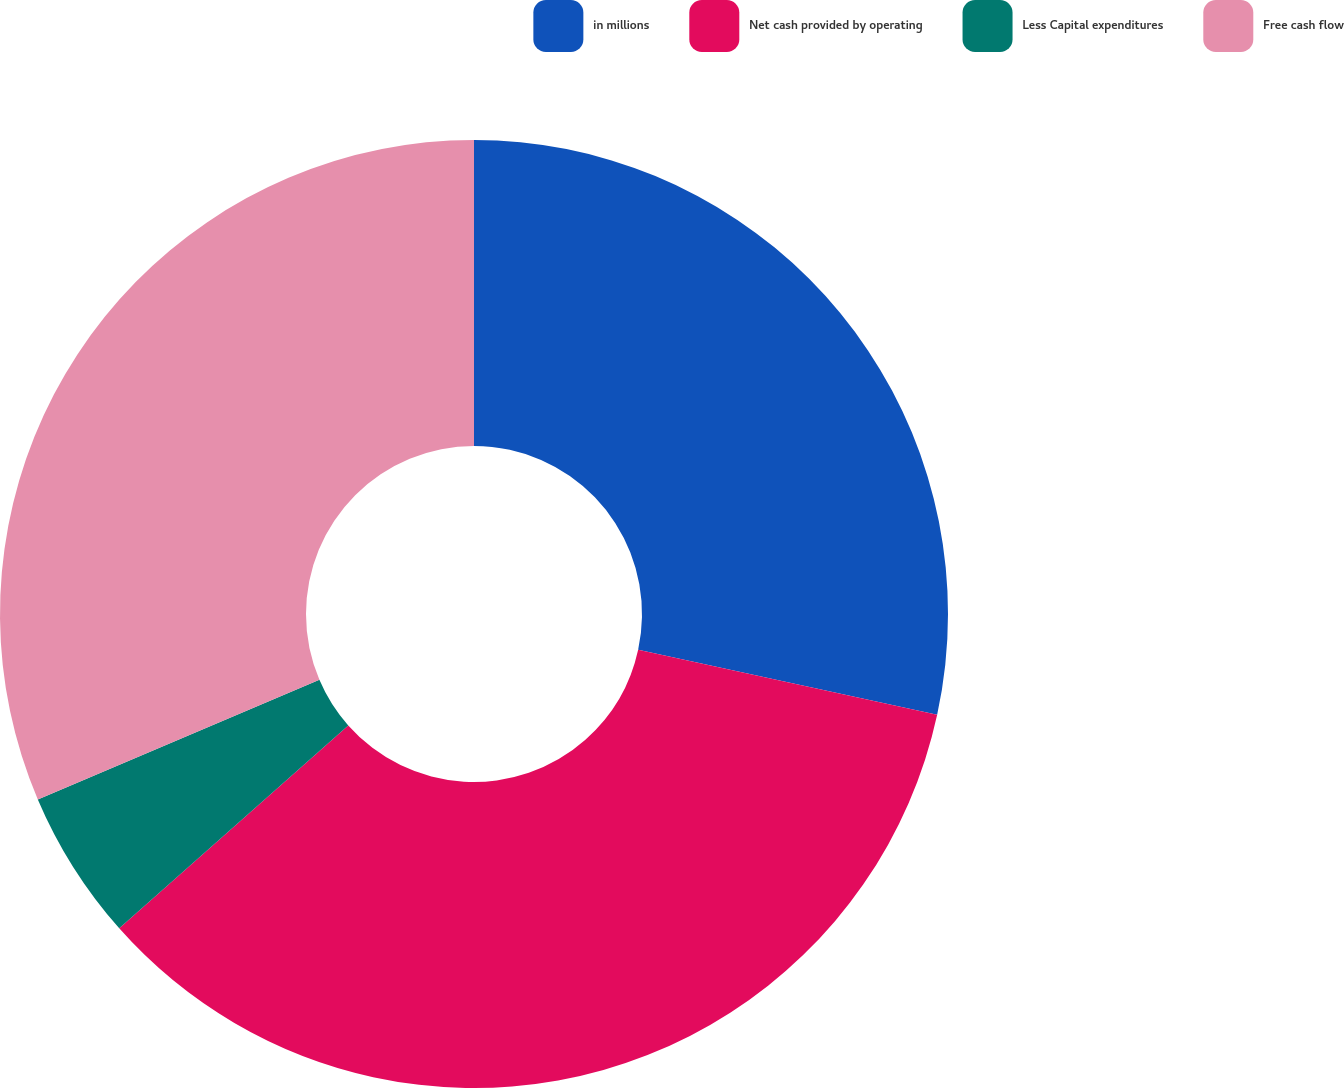<chart> <loc_0><loc_0><loc_500><loc_500><pie_chart><fcel>in millions<fcel>Net cash provided by operating<fcel>Less Capital expenditures<fcel>Free cash flow<nl><fcel>28.41%<fcel>35.05%<fcel>5.14%<fcel>31.4%<nl></chart> 